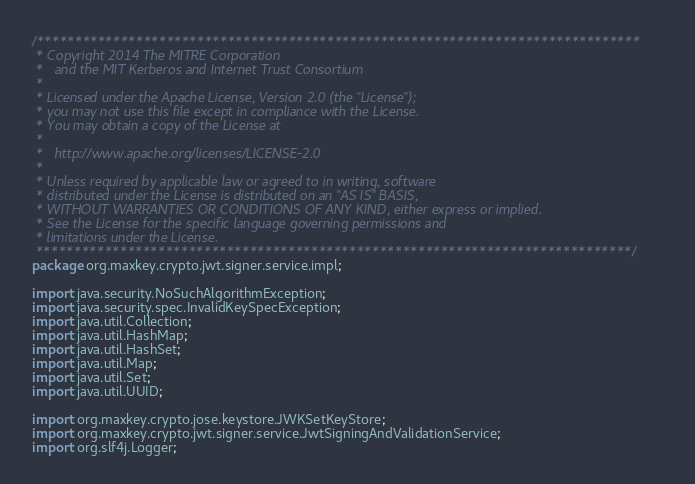Convert code to text. <code><loc_0><loc_0><loc_500><loc_500><_Java_>/*******************************************************************************
 * Copyright 2014 The MITRE Corporation
 *   and the MIT Kerberos and Internet Trust Consortium
 * 
 * Licensed under the Apache License, Version 2.0 (the "License");
 * you may not use this file except in compliance with the License.
 * You may obtain a copy of the License at
 * 
 *   http://www.apache.org/licenses/LICENSE-2.0
 * 
 * Unless required by applicable law or agreed to in writing, software
 * distributed under the License is distributed on an "AS IS" BASIS,
 * WITHOUT WARRANTIES OR CONDITIONS OF ANY KIND, either express or implied.
 * See the License for the specific language governing permissions and
 * limitations under the License.
 ******************************************************************************/
package org.maxkey.crypto.jwt.signer.service.impl;

import java.security.NoSuchAlgorithmException;
import java.security.spec.InvalidKeySpecException;
import java.util.Collection;
import java.util.HashMap;
import java.util.HashSet;
import java.util.Map;
import java.util.Set;
import java.util.UUID;

import org.maxkey.crypto.jose.keystore.JWKSetKeyStore;
import org.maxkey.crypto.jwt.signer.service.JwtSigningAndValidationService;
import org.slf4j.Logger;</code> 